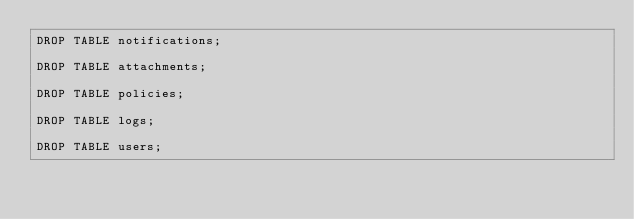Convert code to text. <code><loc_0><loc_0><loc_500><loc_500><_SQL_>DROP TABLE notifications;

DROP TABLE attachments;

DROP TABLE policies;

DROP TABLE logs;

DROP TABLE users;</code> 